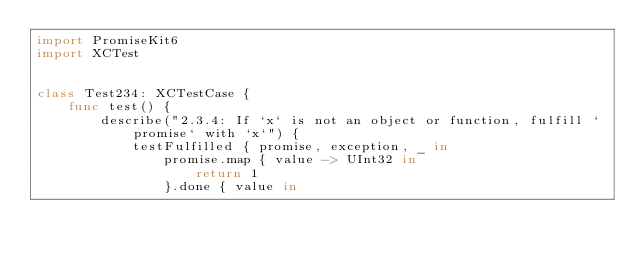Convert code to text. <code><loc_0><loc_0><loc_500><loc_500><_Swift_>import PromiseKit6
import XCTest


class Test234: XCTestCase {
    func test() {
        describe("2.3.4: If `x` is not an object or function, fulfill `promise` with `x`") {
            testFulfilled { promise, exception, _ in
                promise.map { value -> UInt32 in
                    return 1
                }.done { value in</code> 